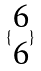<formula> <loc_0><loc_0><loc_500><loc_500>\{ \begin{matrix} 6 \\ 6 \end{matrix} \}</formula> 